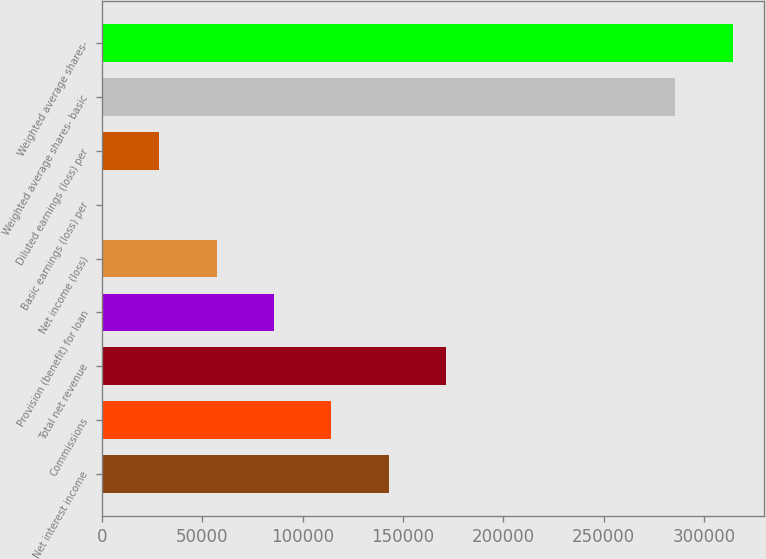Convert chart to OTSL. <chart><loc_0><loc_0><loc_500><loc_500><bar_chart><fcel>Net interest income<fcel>Commissions<fcel>Total net revenue<fcel>Provision (benefit) for loan<fcel>Net income (loss)<fcel>Basic earnings (loss) per<fcel>Diluted earnings (loss) per<fcel>Weighted average shares- basic<fcel>Weighted average shares-<nl><fcel>142874<fcel>114299<fcel>171449<fcel>85724.7<fcel>57149.9<fcel>0.39<fcel>28575.2<fcel>285748<fcel>314323<nl></chart> 